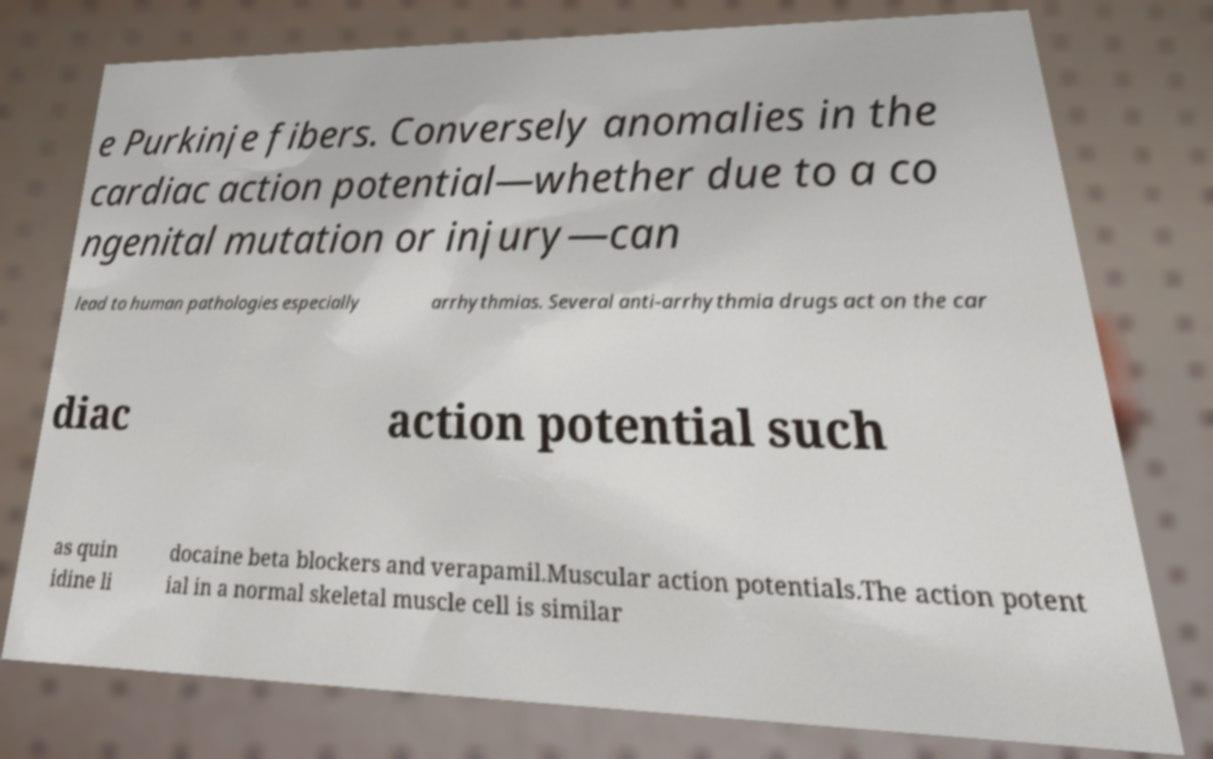For documentation purposes, I need the text within this image transcribed. Could you provide that? e Purkinje fibers. Conversely anomalies in the cardiac action potential—whether due to a co ngenital mutation or injury—can lead to human pathologies especially arrhythmias. Several anti-arrhythmia drugs act on the car diac action potential such as quin idine li docaine beta blockers and verapamil.Muscular action potentials.The action potent ial in a normal skeletal muscle cell is similar 